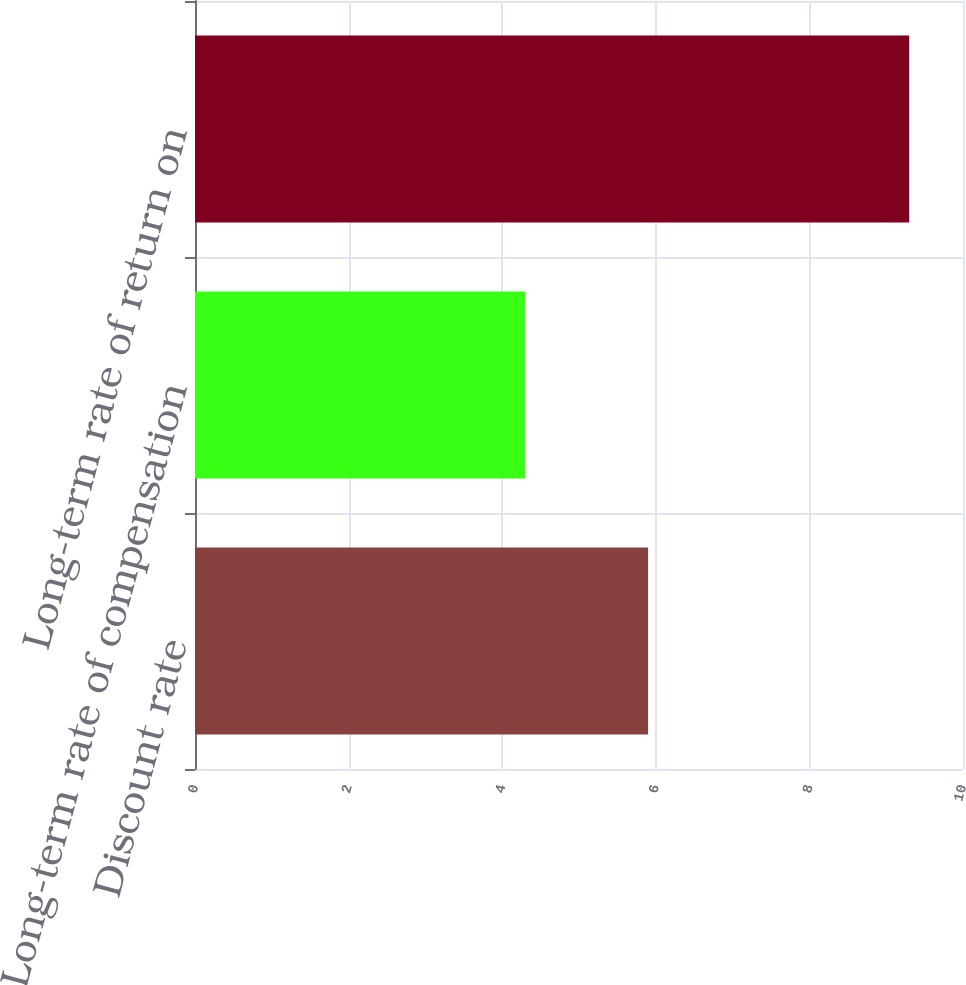Convert chart. <chart><loc_0><loc_0><loc_500><loc_500><bar_chart><fcel>Discount rate<fcel>Long-term rate of compensation<fcel>Long-term rate of return on<nl><fcel>5.9<fcel>4.3<fcel>9.3<nl></chart> 